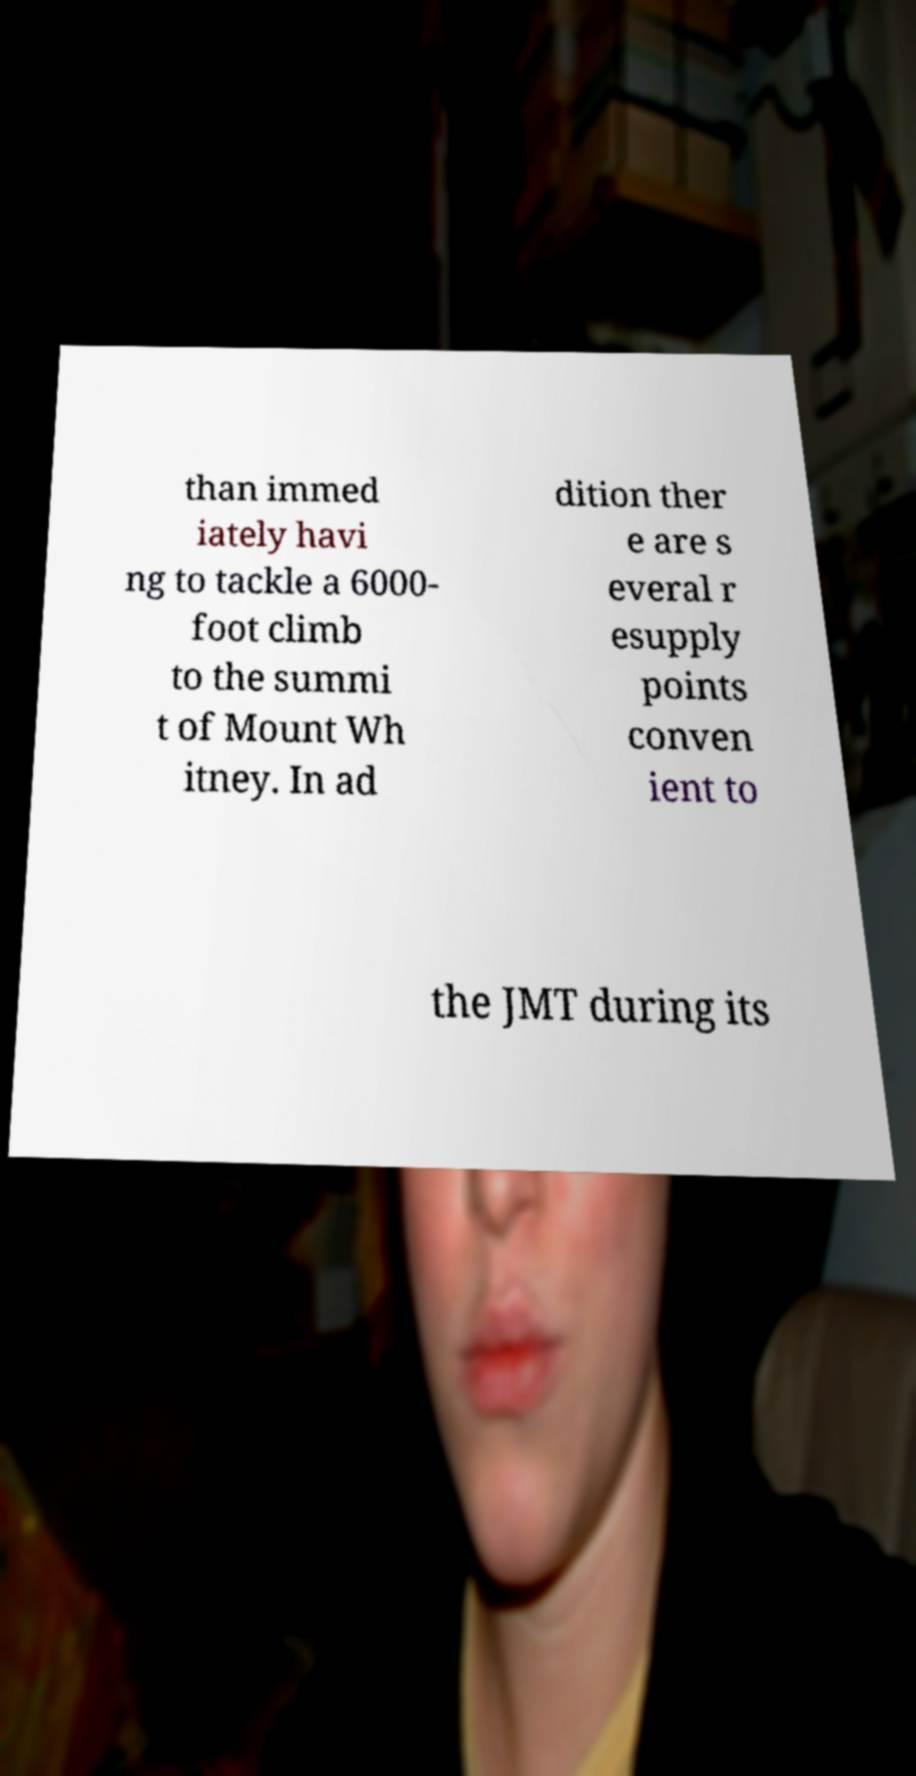Could you extract and type out the text from this image? than immed iately havi ng to tackle a 6000- foot climb to the summi t of Mount Wh itney. In ad dition ther e are s everal r esupply points conven ient to the JMT during its 